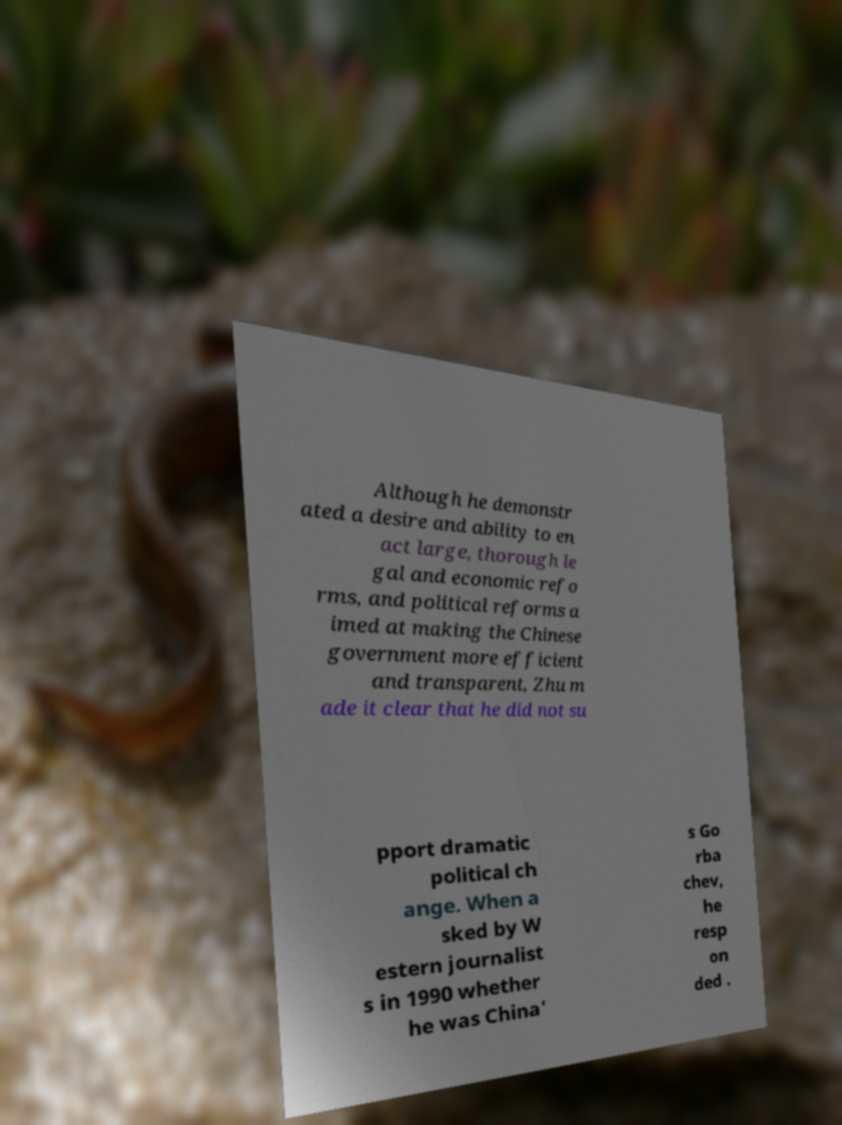Please read and relay the text visible in this image. What does it say? Although he demonstr ated a desire and ability to en act large, thorough le gal and economic refo rms, and political reforms a imed at making the Chinese government more efficient and transparent, Zhu m ade it clear that he did not su pport dramatic political ch ange. When a sked by W estern journalist s in 1990 whether he was China' s Go rba chev, he resp on ded . 